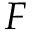<formula> <loc_0><loc_0><loc_500><loc_500>F</formula> 